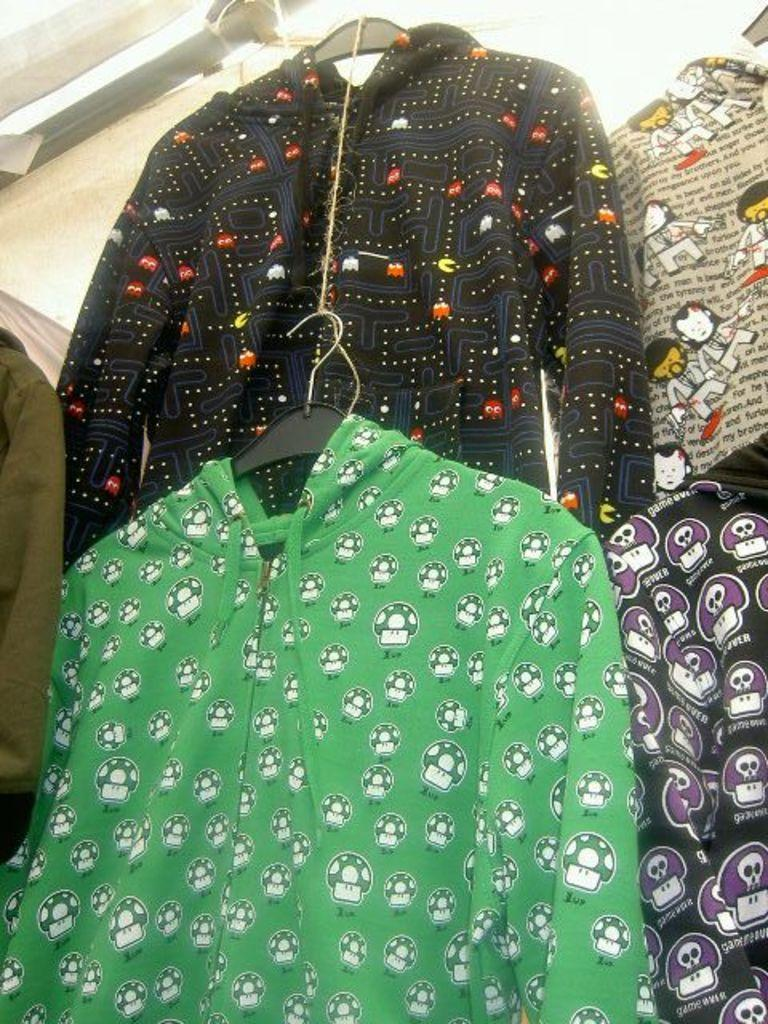What is hanging in the image? There are clothes on hangers in the image. Can you describe the colors of the clothes? The clothes are of different colors. Is there a specific color mentioned for any of the clothes? Yes, one of the colors mentioned is green. What type of legal advice is the lawyer providing in the image? There is no lawyer present in the image, and therefore no legal advice can be observed. What is the person in the image reading? There is no person reading in the image. What time of day is it in the image? The provided facts do not mention any specific time or hour in the image. 